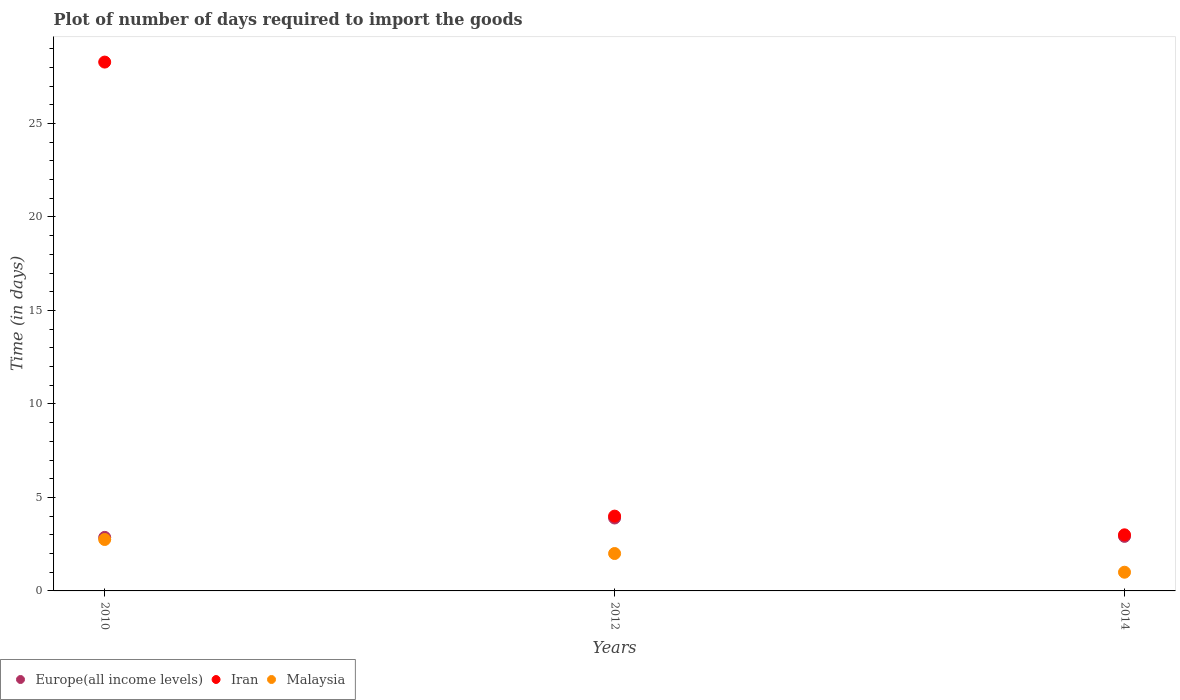What is the time required to import goods in Iran in 2010?
Your answer should be very brief. 28.28. Across all years, what is the maximum time required to import goods in Iran?
Your answer should be very brief. 28.28. Across all years, what is the minimum time required to import goods in Iran?
Your response must be concise. 3. In which year was the time required to import goods in Europe(all income levels) maximum?
Keep it short and to the point. 2012. In which year was the time required to import goods in Iran minimum?
Give a very brief answer. 2014. What is the total time required to import goods in Iran in the graph?
Your answer should be very brief. 35.28. What is the difference between the time required to import goods in Malaysia in 2010 and that in 2014?
Offer a very short reply. 1.75. What is the difference between the time required to import goods in Iran in 2014 and the time required to import goods in Malaysia in 2012?
Make the answer very short. 1. What is the average time required to import goods in Malaysia per year?
Keep it short and to the point. 1.92. In how many years, is the time required to import goods in Malaysia greater than 14 days?
Your answer should be very brief. 0. What is the ratio of the time required to import goods in Europe(all income levels) in 2010 to that in 2014?
Your response must be concise. 0.98. Is the time required to import goods in Malaysia in 2010 less than that in 2014?
Provide a short and direct response. No. Is the difference between the time required to import goods in Iran in 2010 and 2012 greater than the difference between the time required to import goods in Malaysia in 2010 and 2012?
Your response must be concise. Yes. What is the difference between the highest and the lowest time required to import goods in Iran?
Offer a terse response. 25.28. Is the sum of the time required to import goods in Malaysia in 2012 and 2014 greater than the maximum time required to import goods in Iran across all years?
Give a very brief answer. No. Does the time required to import goods in Europe(all income levels) monotonically increase over the years?
Make the answer very short. No. Is the time required to import goods in Europe(all income levels) strictly greater than the time required to import goods in Malaysia over the years?
Provide a short and direct response. Yes. How many dotlines are there?
Make the answer very short. 3. What is the difference between two consecutive major ticks on the Y-axis?
Offer a terse response. 5. Are the values on the major ticks of Y-axis written in scientific E-notation?
Make the answer very short. No. Where does the legend appear in the graph?
Make the answer very short. Bottom left. How many legend labels are there?
Your response must be concise. 3. How are the legend labels stacked?
Your answer should be compact. Horizontal. What is the title of the graph?
Your response must be concise. Plot of number of days required to import the goods. Does "Hungary" appear as one of the legend labels in the graph?
Keep it short and to the point. No. What is the label or title of the X-axis?
Your response must be concise. Years. What is the label or title of the Y-axis?
Give a very brief answer. Time (in days). What is the Time (in days) in Europe(all income levels) in 2010?
Ensure brevity in your answer.  2.86. What is the Time (in days) in Iran in 2010?
Make the answer very short. 28.28. What is the Time (in days) in Malaysia in 2010?
Your response must be concise. 2.75. What is the Time (in days) of Europe(all income levels) in 2012?
Provide a succinct answer. 3.9. What is the Time (in days) of Malaysia in 2012?
Offer a terse response. 2. What is the Time (in days) in Europe(all income levels) in 2014?
Offer a very short reply. 2.92. What is the Time (in days) of Iran in 2014?
Your response must be concise. 3. What is the Time (in days) in Malaysia in 2014?
Provide a short and direct response. 1. Across all years, what is the maximum Time (in days) of Europe(all income levels)?
Your response must be concise. 3.9. Across all years, what is the maximum Time (in days) of Iran?
Ensure brevity in your answer.  28.28. Across all years, what is the maximum Time (in days) in Malaysia?
Your response must be concise. 2.75. Across all years, what is the minimum Time (in days) of Europe(all income levels)?
Your answer should be compact. 2.86. Across all years, what is the minimum Time (in days) of Iran?
Provide a short and direct response. 3. What is the total Time (in days) of Europe(all income levels) in the graph?
Keep it short and to the point. 9.68. What is the total Time (in days) of Iran in the graph?
Offer a terse response. 35.28. What is the total Time (in days) in Malaysia in the graph?
Provide a succinct answer. 5.75. What is the difference between the Time (in days) of Europe(all income levels) in 2010 and that in 2012?
Provide a succinct answer. -1.04. What is the difference between the Time (in days) in Iran in 2010 and that in 2012?
Your answer should be compact. 24.28. What is the difference between the Time (in days) in Europe(all income levels) in 2010 and that in 2014?
Your answer should be compact. -0.05. What is the difference between the Time (in days) of Iran in 2010 and that in 2014?
Give a very brief answer. 25.28. What is the difference between the Time (in days) in Europe(all income levels) in 2012 and that in 2014?
Keep it short and to the point. 0.98. What is the difference between the Time (in days) of Iran in 2012 and that in 2014?
Make the answer very short. 1. What is the difference between the Time (in days) in Malaysia in 2012 and that in 2014?
Ensure brevity in your answer.  1. What is the difference between the Time (in days) in Europe(all income levels) in 2010 and the Time (in days) in Iran in 2012?
Give a very brief answer. -1.14. What is the difference between the Time (in days) of Europe(all income levels) in 2010 and the Time (in days) of Malaysia in 2012?
Offer a very short reply. 0.86. What is the difference between the Time (in days) of Iran in 2010 and the Time (in days) of Malaysia in 2012?
Ensure brevity in your answer.  26.28. What is the difference between the Time (in days) in Europe(all income levels) in 2010 and the Time (in days) in Iran in 2014?
Offer a terse response. -0.14. What is the difference between the Time (in days) of Europe(all income levels) in 2010 and the Time (in days) of Malaysia in 2014?
Give a very brief answer. 1.86. What is the difference between the Time (in days) in Iran in 2010 and the Time (in days) in Malaysia in 2014?
Give a very brief answer. 27.28. What is the difference between the Time (in days) of Europe(all income levels) in 2012 and the Time (in days) of Iran in 2014?
Offer a terse response. 0.9. What is the difference between the Time (in days) of Iran in 2012 and the Time (in days) of Malaysia in 2014?
Your answer should be compact. 3. What is the average Time (in days) in Europe(all income levels) per year?
Offer a terse response. 3.23. What is the average Time (in days) of Iran per year?
Give a very brief answer. 11.76. What is the average Time (in days) in Malaysia per year?
Your answer should be very brief. 1.92. In the year 2010, what is the difference between the Time (in days) in Europe(all income levels) and Time (in days) in Iran?
Your answer should be very brief. -25.42. In the year 2010, what is the difference between the Time (in days) in Europe(all income levels) and Time (in days) in Malaysia?
Your answer should be compact. 0.11. In the year 2010, what is the difference between the Time (in days) of Iran and Time (in days) of Malaysia?
Provide a succinct answer. 25.53. In the year 2012, what is the difference between the Time (in days) of Iran and Time (in days) of Malaysia?
Offer a very short reply. 2. In the year 2014, what is the difference between the Time (in days) of Europe(all income levels) and Time (in days) of Iran?
Give a very brief answer. -0.08. In the year 2014, what is the difference between the Time (in days) of Europe(all income levels) and Time (in days) of Malaysia?
Make the answer very short. 1.92. What is the ratio of the Time (in days) in Europe(all income levels) in 2010 to that in 2012?
Offer a very short reply. 0.73. What is the ratio of the Time (in days) in Iran in 2010 to that in 2012?
Make the answer very short. 7.07. What is the ratio of the Time (in days) in Malaysia in 2010 to that in 2012?
Ensure brevity in your answer.  1.38. What is the ratio of the Time (in days) in Europe(all income levels) in 2010 to that in 2014?
Ensure brevity in your answer.  0.98. What is the ratio of the Time (in days) of Iran in 2010 to that in 2014?
Offer a very short reply. 9.43. What is the ratio of the Time (in days) in Malaysia in 2010 to that in 2014?
Your answer should be very brief. 2.75. What is the ratio of the Time (in days) in Europe(all income levels) in 2012 to that in 2014?
Ensure brevity in your answer.  1.34. What is the difference between the highest and the second highest Time (in days) of Europe(all income levels)?
Your answer should be very brief. 0.98. What is the difference between the highest and the second highest Time (in days) in Iran?
Offer a terse response. 24.28. What is the difference between the highest and the second highest Time (in days) in Malaysia?
Your answer should be very brief. 0.75. What is the difference between the highest and the lowest Time (in days) in Europe(all income levels)?
Ensure brevity in your answer.  1.04. What is the difference between the highest and the lowest Time (in days) in Iran?
Give a very brief answer. 25.28. What is the difference between the highest and the lowest Time (in days) in Malaysia?
Provide a short and direct response. 1.75. 